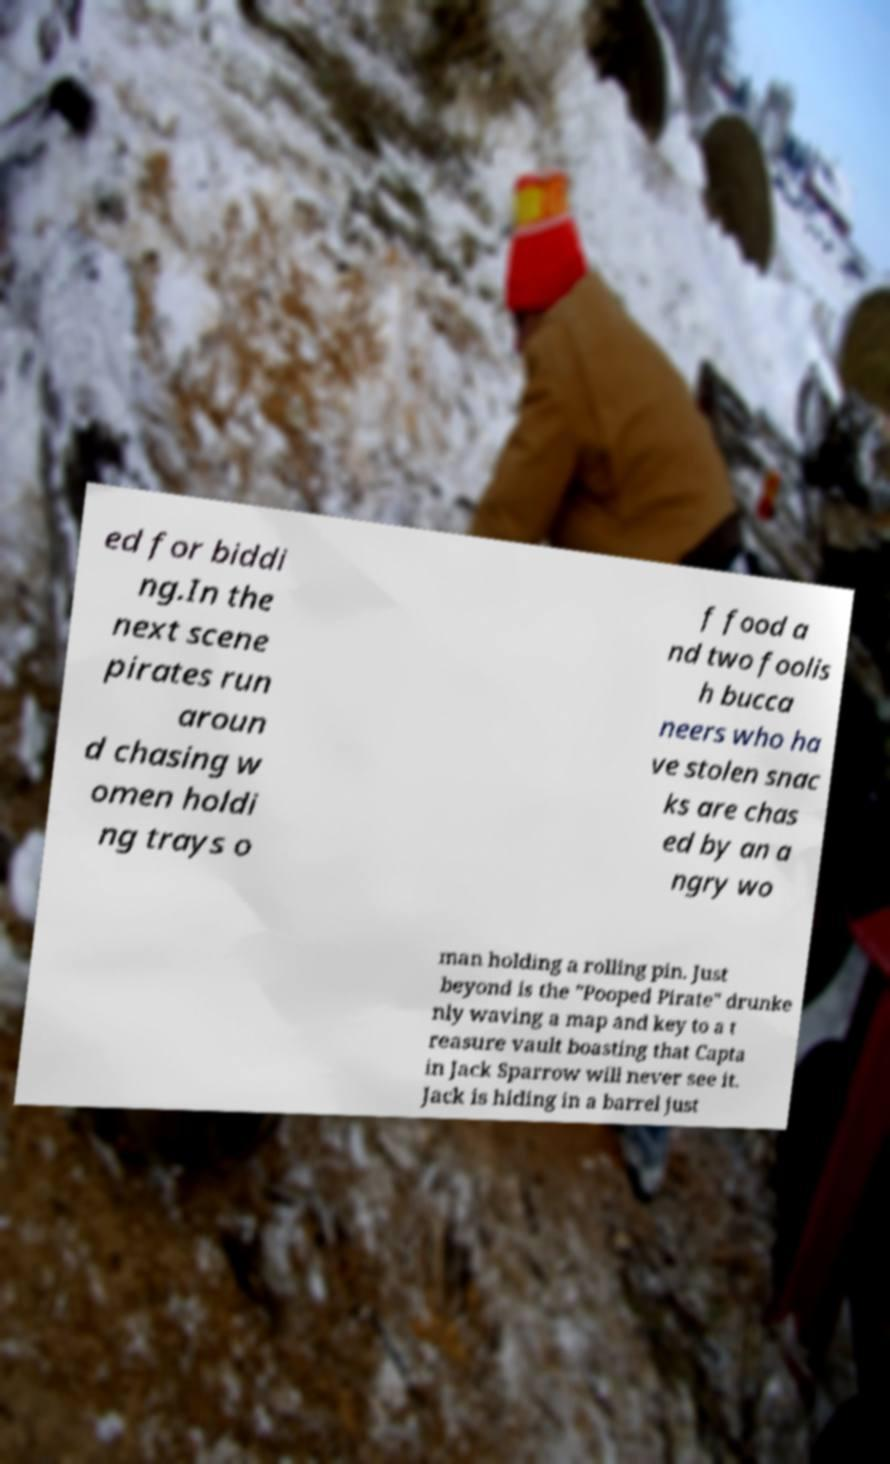There's text embedded in this image that I need extracted. Can you transcribe it verbatim? ed for biddi ng.In the next scene pirates run aroun d chasing w omen holdi ng trays o f food a nd two foolis h bucca neers who ha ve stolen snac ks are chas ed by an a ngry wo man holding a rolling pin. Just beyond is the "Pooped Pirate" drunke nly waving a map and key to a t reasure vault boasting that Capta in Jack Sparrow will never see it. Jack is hiding in a barrel just 